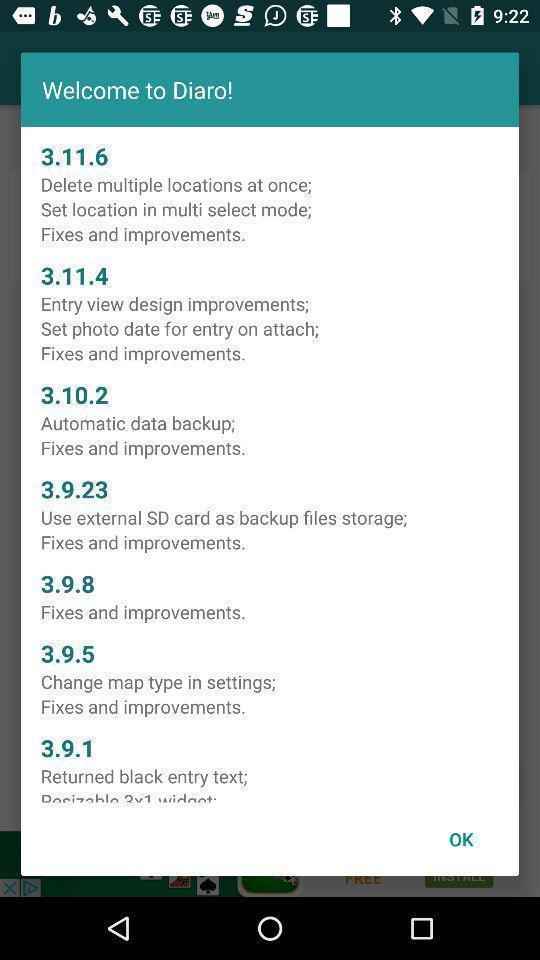Give me a narrative description of this picture. Welcome page. 